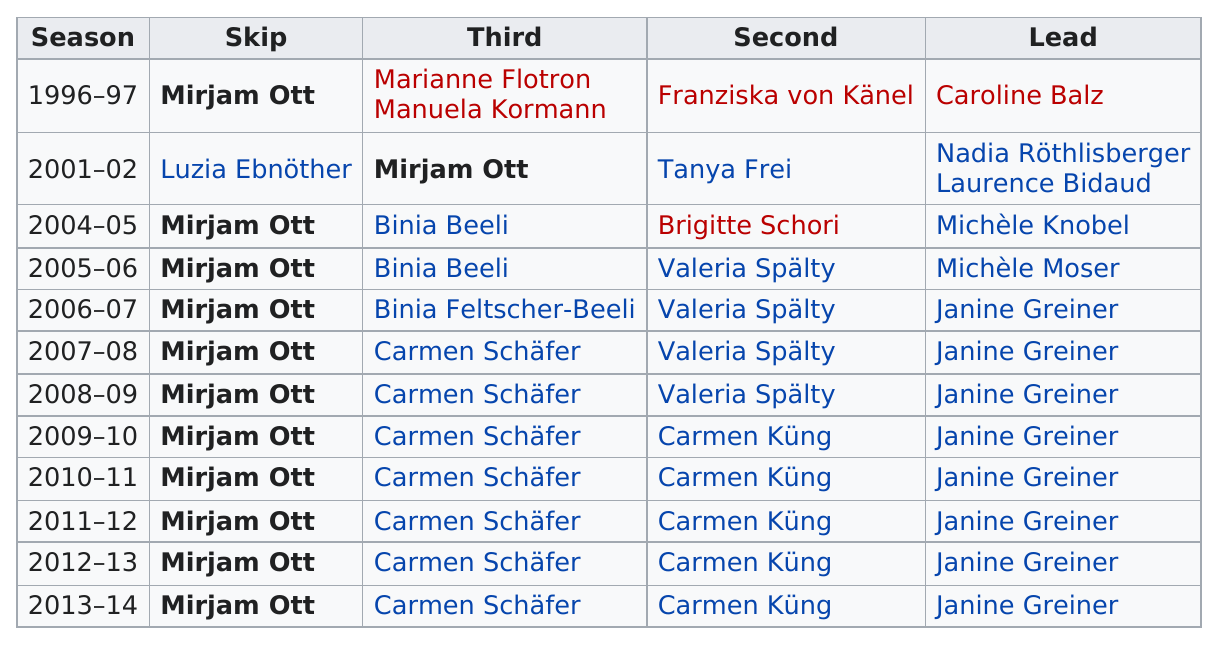Mention a couple of crucial points in this snapshot. For the past 11 seasons, Ott has served as the skip. 